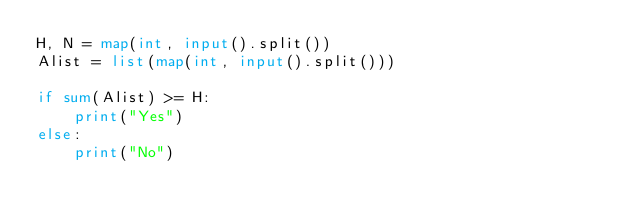Convert code to text. <code><loc_0><loc_0><loc_500><loc_500><_Python_>H, N = map(int, input().split())
Alist = list(map(int, input().split()))

if sum(Alist) >= H:
    print("Yes")
else:
    print("No")</code> 